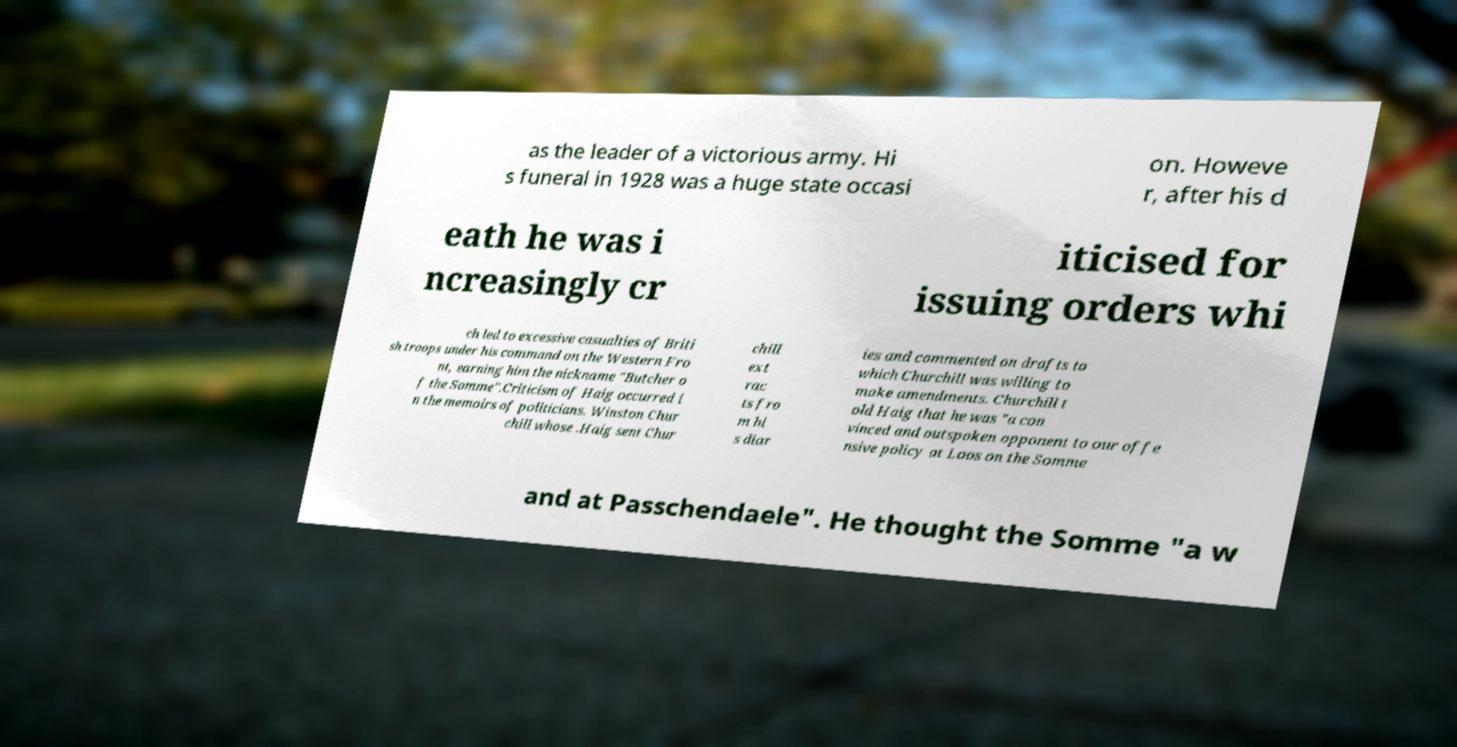For documentation purposes, I need the text within this image transcribed. Could you provide that? as the leader of a victorious army. Hi s funeral in 1928 was a huge state occasi on. Howeve r, after his d eath he was i ncreasingly cr iticised for issuing orders whi ch led to excessive casualties of Briti sh troops under his command on the Western Fro nt, earning him the nickname "Butcher o f the Somme".Criticism of Haig occurred i n the memoirs of politicians. Winston Chur chill whose .Haig sent Chur chill ext rac ts fro m hi s diar ies and commented on drafts to which Churchill was willing to make amendments. Churchill t old Haig that he was "a con vinced and outspoken opponent to our offe nsive policy at Loos on the Somme and at Passchendaele". He thought the Somme "a w 